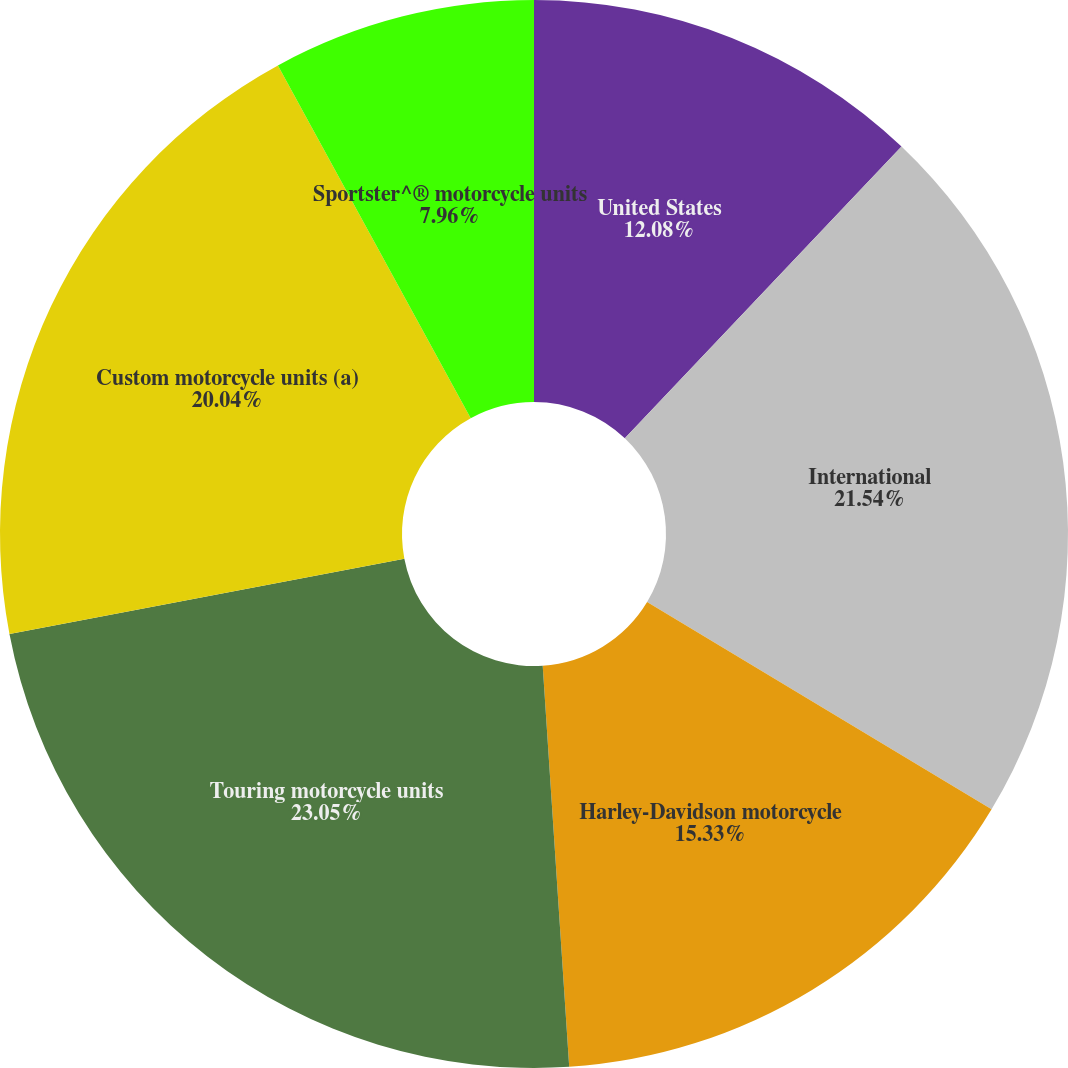Convert chart. <chart><loc_0><loc_0><loc_500><loc_500><pie_chart><fcel>United States<fcel>International<fcel>Harley-Davidson motorcycle<fcel>Touring motorcycle units<fcel>Custom motorcycle units (a)<fcel>Sportster^® motorcycle units<nl><fcel>12.08%<fcel>21.54%<fcel>15.33%<fcel>23.05%<fcel>20.04%<fcel>7.96%<nl></chart> 